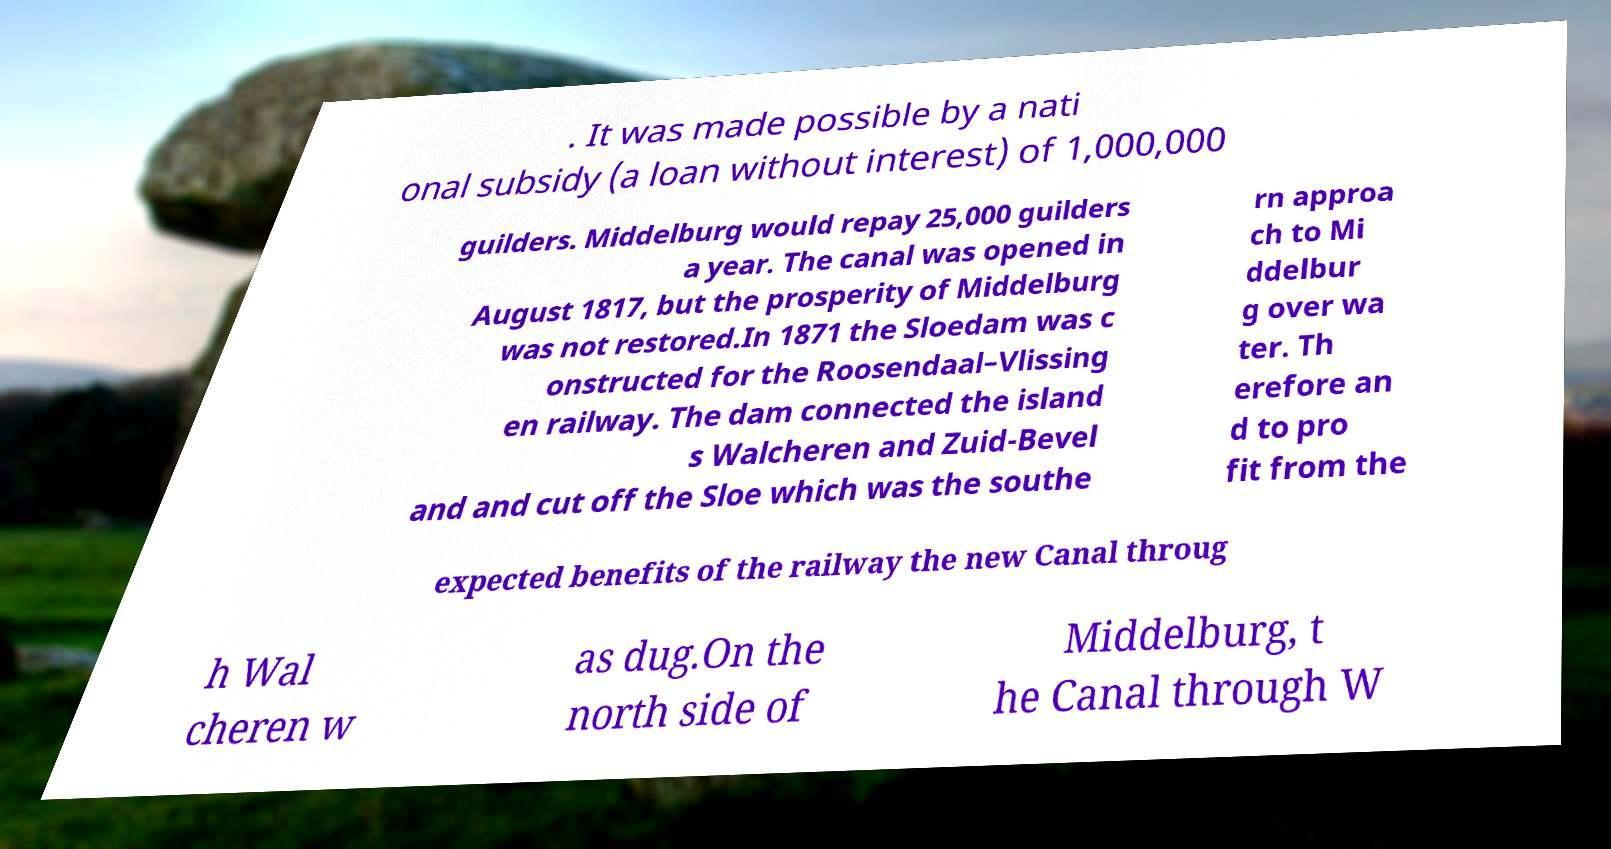Please read and relay the text visible in this image. What does it say? . It was made possible by a nati onal subsidy (a loan without interest) of 1,000,000 guilders. Middelburg would repay 25,000 guilders a year. The canal was opened in August 1817, but the prosperity of Middelburg was not restored.In 1871 the Sloedam was c onstructed for the Roosendaal–Vlissing en railway. The dam connected the island s Walcheren and Zuid-Bevel and and cut off the Sloe which was the southe rn approa ch to Mi ddelbur g over wa ter. Th erefore an d to pro fit from the expected benefits of the railway the new Canal throug h Wal cheren w as dug.On the north side of Middelburg, t he Canal through W 